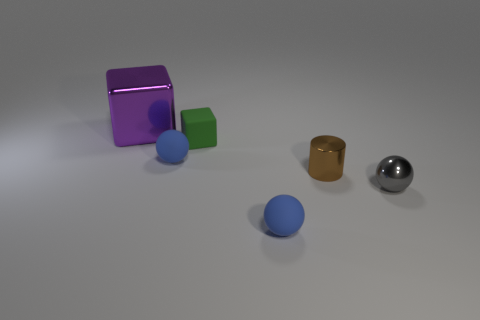What number of other things are there of the same color as the large thing?
Your answer should be very brief. 0. Are there any other things that have the same material as the small green thing?
Provide a short and direct response. Yes. What is the size of the other object that is the same shape as the tiny green matte object?
Offer a terse response. Large. Is the number of tiny gray shiny things right of the gray ball greater than the number of gray things?
Your answer should be compact. No. Does the ball that is in front of the tiny gray metallic object have the same material as the gray object?
Your answer should be very brief. No. There is a blue ball that is on the right side of the cube that is in front of the big object that is to the left of the small green thing; what is its size?
Offer a terse response. Small. There is a purple thing that is the same material as the small brown cylinder; what is its size?
Provide a succinct answer. Large. What color is the tiny sphere that is on the left side of the gray thing and in front of the brown object?
Make the answer very short. Blue. There is a tiny thing that is in front of the shiny sphere; does it have the same shape as the tiny shiny thing that is behind the tiny gray metal sphere?
Provide a succinct answer. No. There is a block in front of the purple cube; what is its material?
Give a very brief answer. Rubber. 